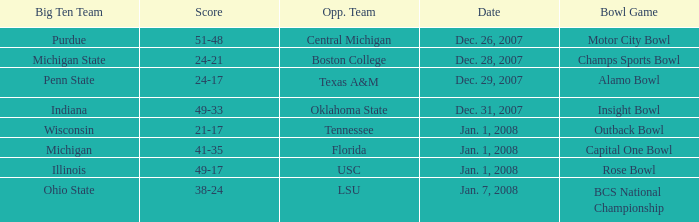What was the outcome of the insight bowl? 49-33. 